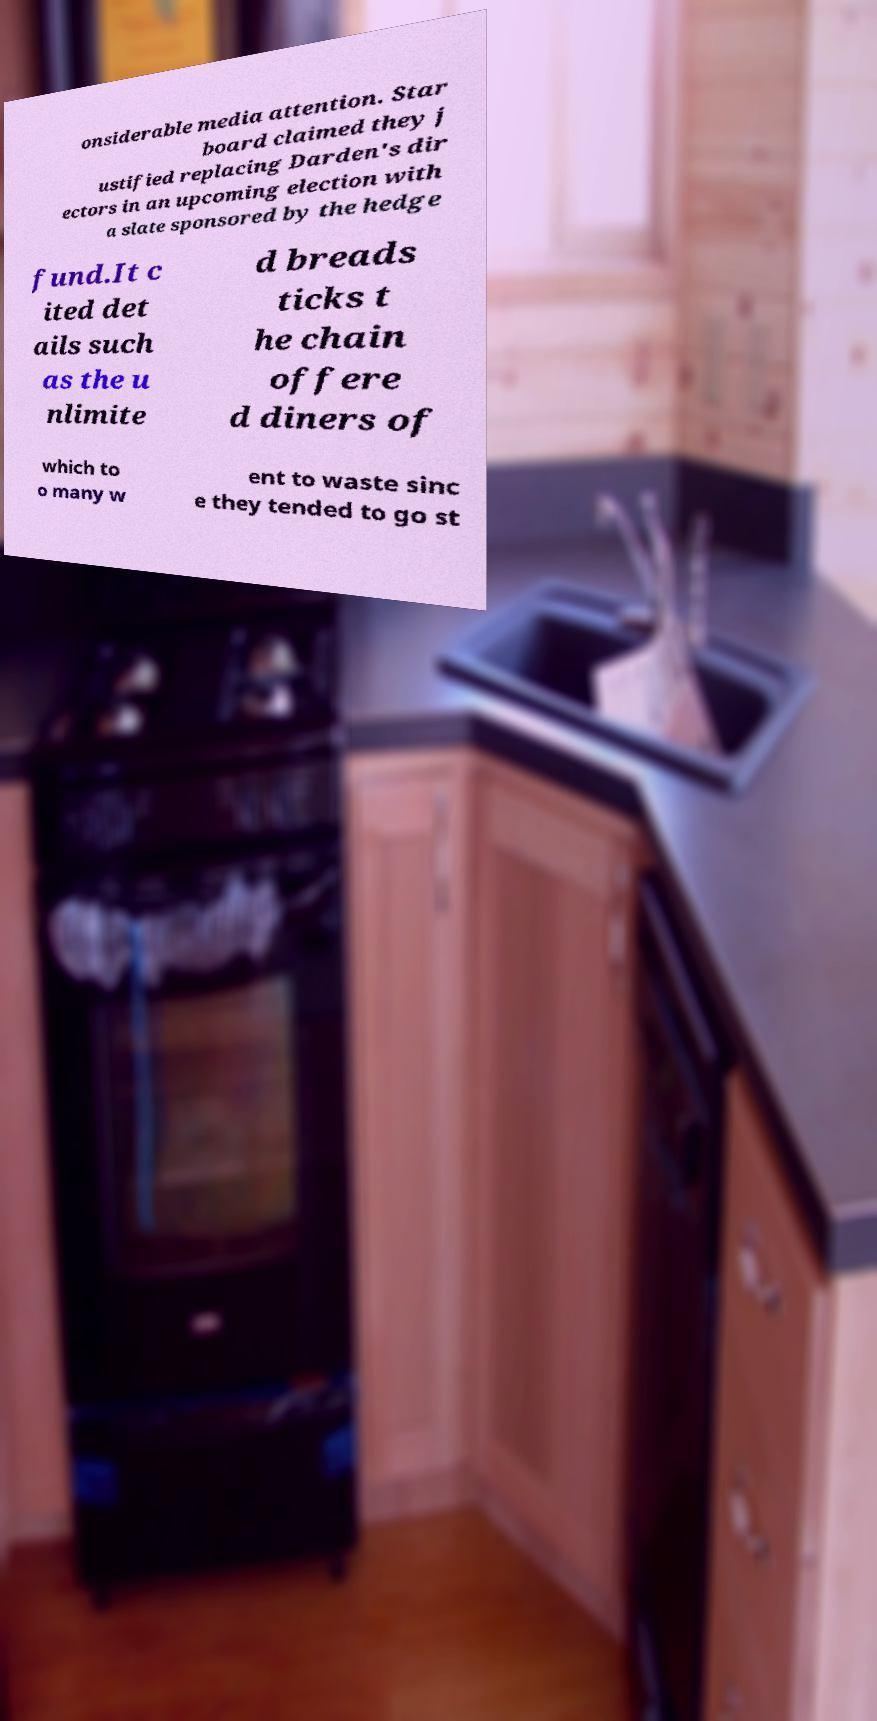What messages or text are displayed in this image? I need them in a readable, typed format. onsiderable media attention. Star board claimed they j ustified replacing Darden's dir ectors in an upcoming election with a slate sponsored by the hedge fund.It c ited det ails such as the u nlimite d breads ticks t he chain offere d diners of which to o many w ent to waste sinc e they tended to go st 